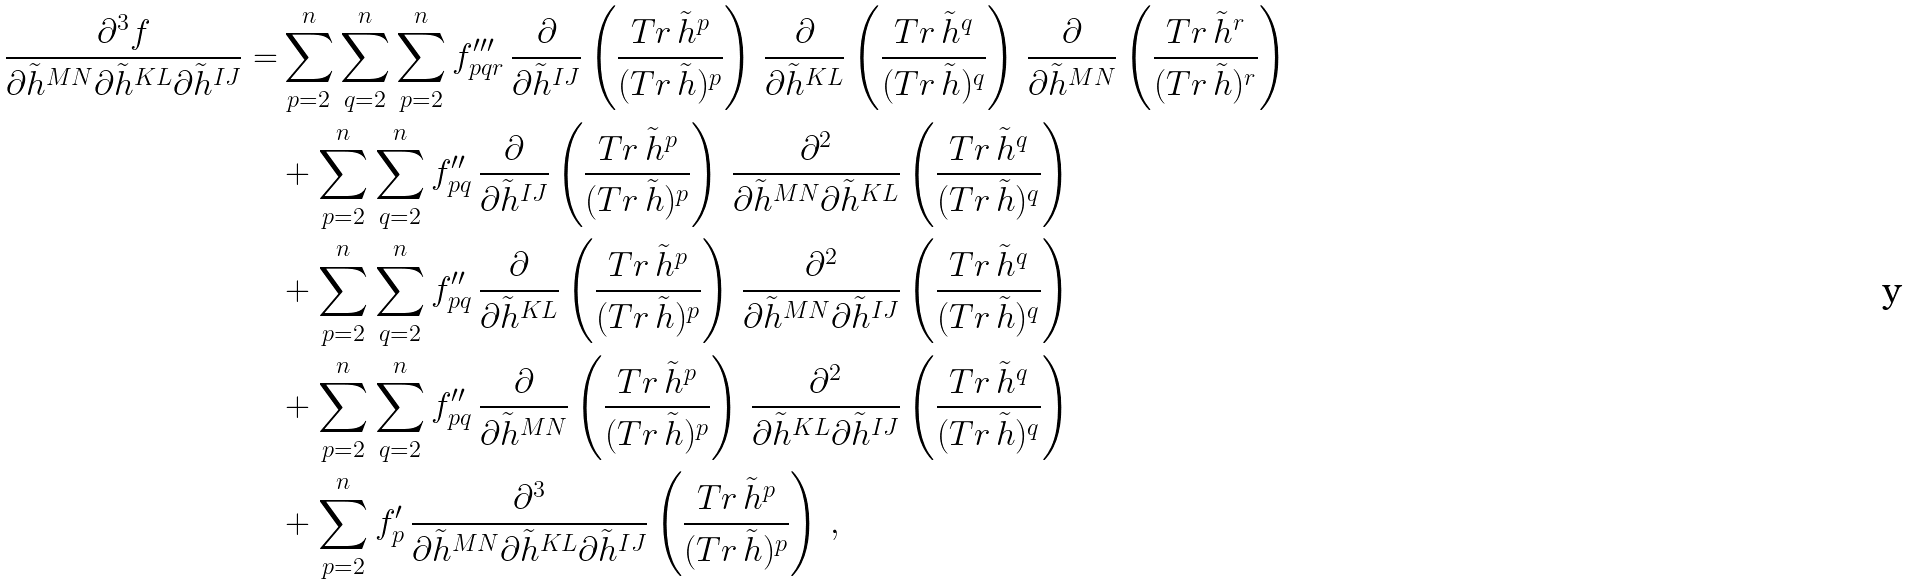<formula> <loc_0><loc_0><loc_500><loc_500>\frac { \partial ^ { 3 } f } { \partial \tilde { h } ^ { M N } \partial \tilde { h } ^ { K L } \partial \tilde { h } ^ { I J } } = & \sum _ { p = 2 } ^ { n } \sum _ { q = 2 } ^ { n } \sum _ { p = 2 } ^ { n } f ^ { \prime \prime \prime } _ { p q r } \, \frac { \partial } { \partial \tilde { h } ^ { I J } } \left ( \frac { T r \, \tilde { h } ^ { p } } { ( T r \, \tilde { h } ) ^ { p } } \right ) \, \frac { \partial } { \partial \tilde { h } ^ { K L } } \left ( \frac { T r \, \tilde { h } ^ { q } } { ( T r \, \tilde { h } ) ^ { q } } \right ) \, \frac { \partial } { \partial \tilde { h } ^ { M N } } \left ( \frac { T r \, \tilde { h } ^ { r } } { ( T r \, \tilde { h } ) ^ { r } } \right ) \\ & + \sum _ { p = 2 } ^ { n } \sum _ { q = 2 } ^ { n } f ^ { \prime \prime } _ { p q } \, \frac { \partial } { \partial \tilde { h } ^ { I J } } \left ( \frac { T r \, \tilde { h } ^ { p } } { ( T r \, \tilde { h } ) ^ { p } } \right ) \, \frac { \partial ^ { 2 } } { \partial \tilde { h } ^ { M N } \partial \tilde { h } ^ { K L } } \left ( \frac { T r \, \tilde { h } ^ { q } } { ( T r \, \tilde { h } ) ^ { q } } \right ) \\ & + \sum _ { p = 2 } ^ { n } \sum _ { q = 2 } ^ { n } f ^ { \prime \prime } _ { p q } \, \frac { \partial } { \partial \tilde { h } ^ { K L } } \left ( \frac { T r \, \tilde { h } ^ { p } } { ( T r \, \tilde { h } ) ^ { p } } \right ) \, \frac { \partial ^ { 2 } } { \partial \tilde { h } ^ { M N } \partial \tilde { h } ^ { I J } } \left ( \frac { T r \, \tilde { h } ^ { q } } { ( T r \, \tilde { h } ) ^ { q } } \right ) \\ & + \sum _ { p = 2 } ^ { n } \sum _ { q = 2 } ^ { n } f ^ { \prime \prime } _ { p q } \, \frac { \partial } { \partial \tilde { h } ^ { M N } } \left ( \frac { T r \, \tilde { h } ^ { p } } { ( T r \, \tilde { h } ) ^ { p } } \right ) \, \frac { \partial ^ { 2 } } { \partial \tilde { h } ^ { K L } \partial \tilde { h } ^ { I J } } \left ( \frac { T r \, \tilde { h } ^ { q } } { ( T r \, \tilde { h } ) ^ { q } } \right ) \\ & + \sum _ { p = 2 } ^ { n } f ^ { \prime } _ { p } \, \frac { \partial ^ { 3 } } { \partial \tilde { h } ^ { M N } \partial \tilde { h } ^ { K L } \partial \tilde { h } ^ { I J } } \left ( \frac { T r \, \tilde { h } ^ { p } } { ( T r \, \tilde { h } ) ^ { p } } \right ) \, ,</formula> 